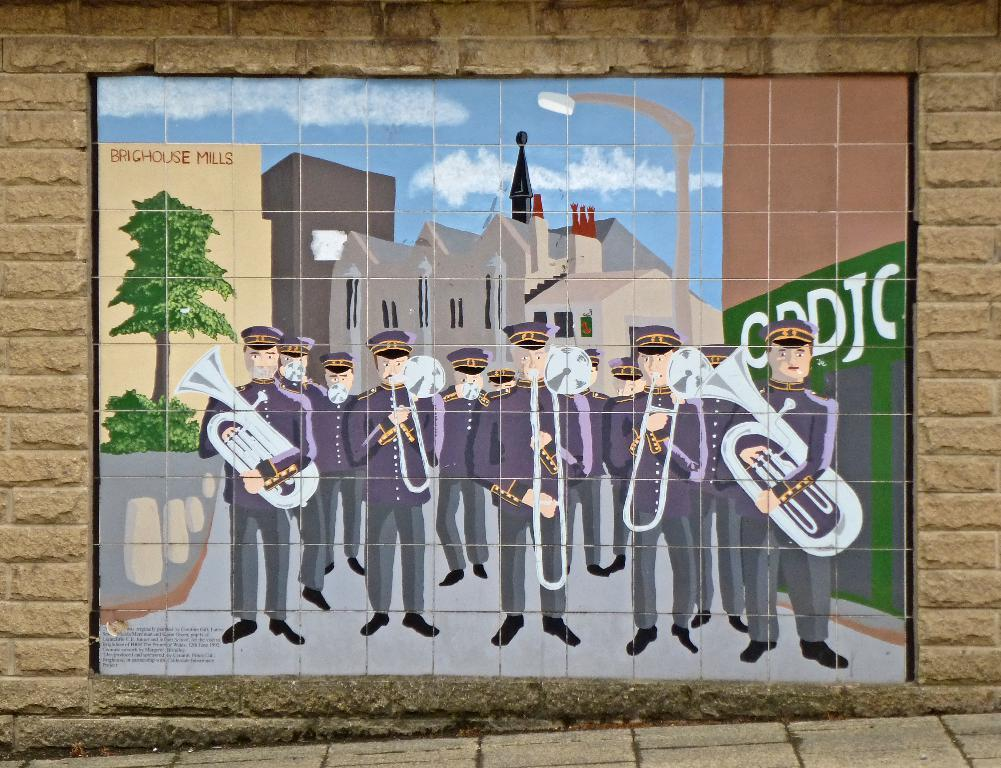What is on the wall in the image? There is a board on the wall in the image. What are the people in the image doing? The group of people is standing on the ground in the image. What objects can be seen in the image that are related to music? Musical instruments are visible in the image. What type of structures can be seen in the image? There are buildings in the image. What type of vegetation is present in the image? Trees are present in the image. What part of the natural environment is visible in the image? The sky is visible in the image. What book is the person holding in the image? There is no book present in the image. What type of voice can be heard coming from the person in the image? There is no voice or audio present in the image, as it is a still photograph. 